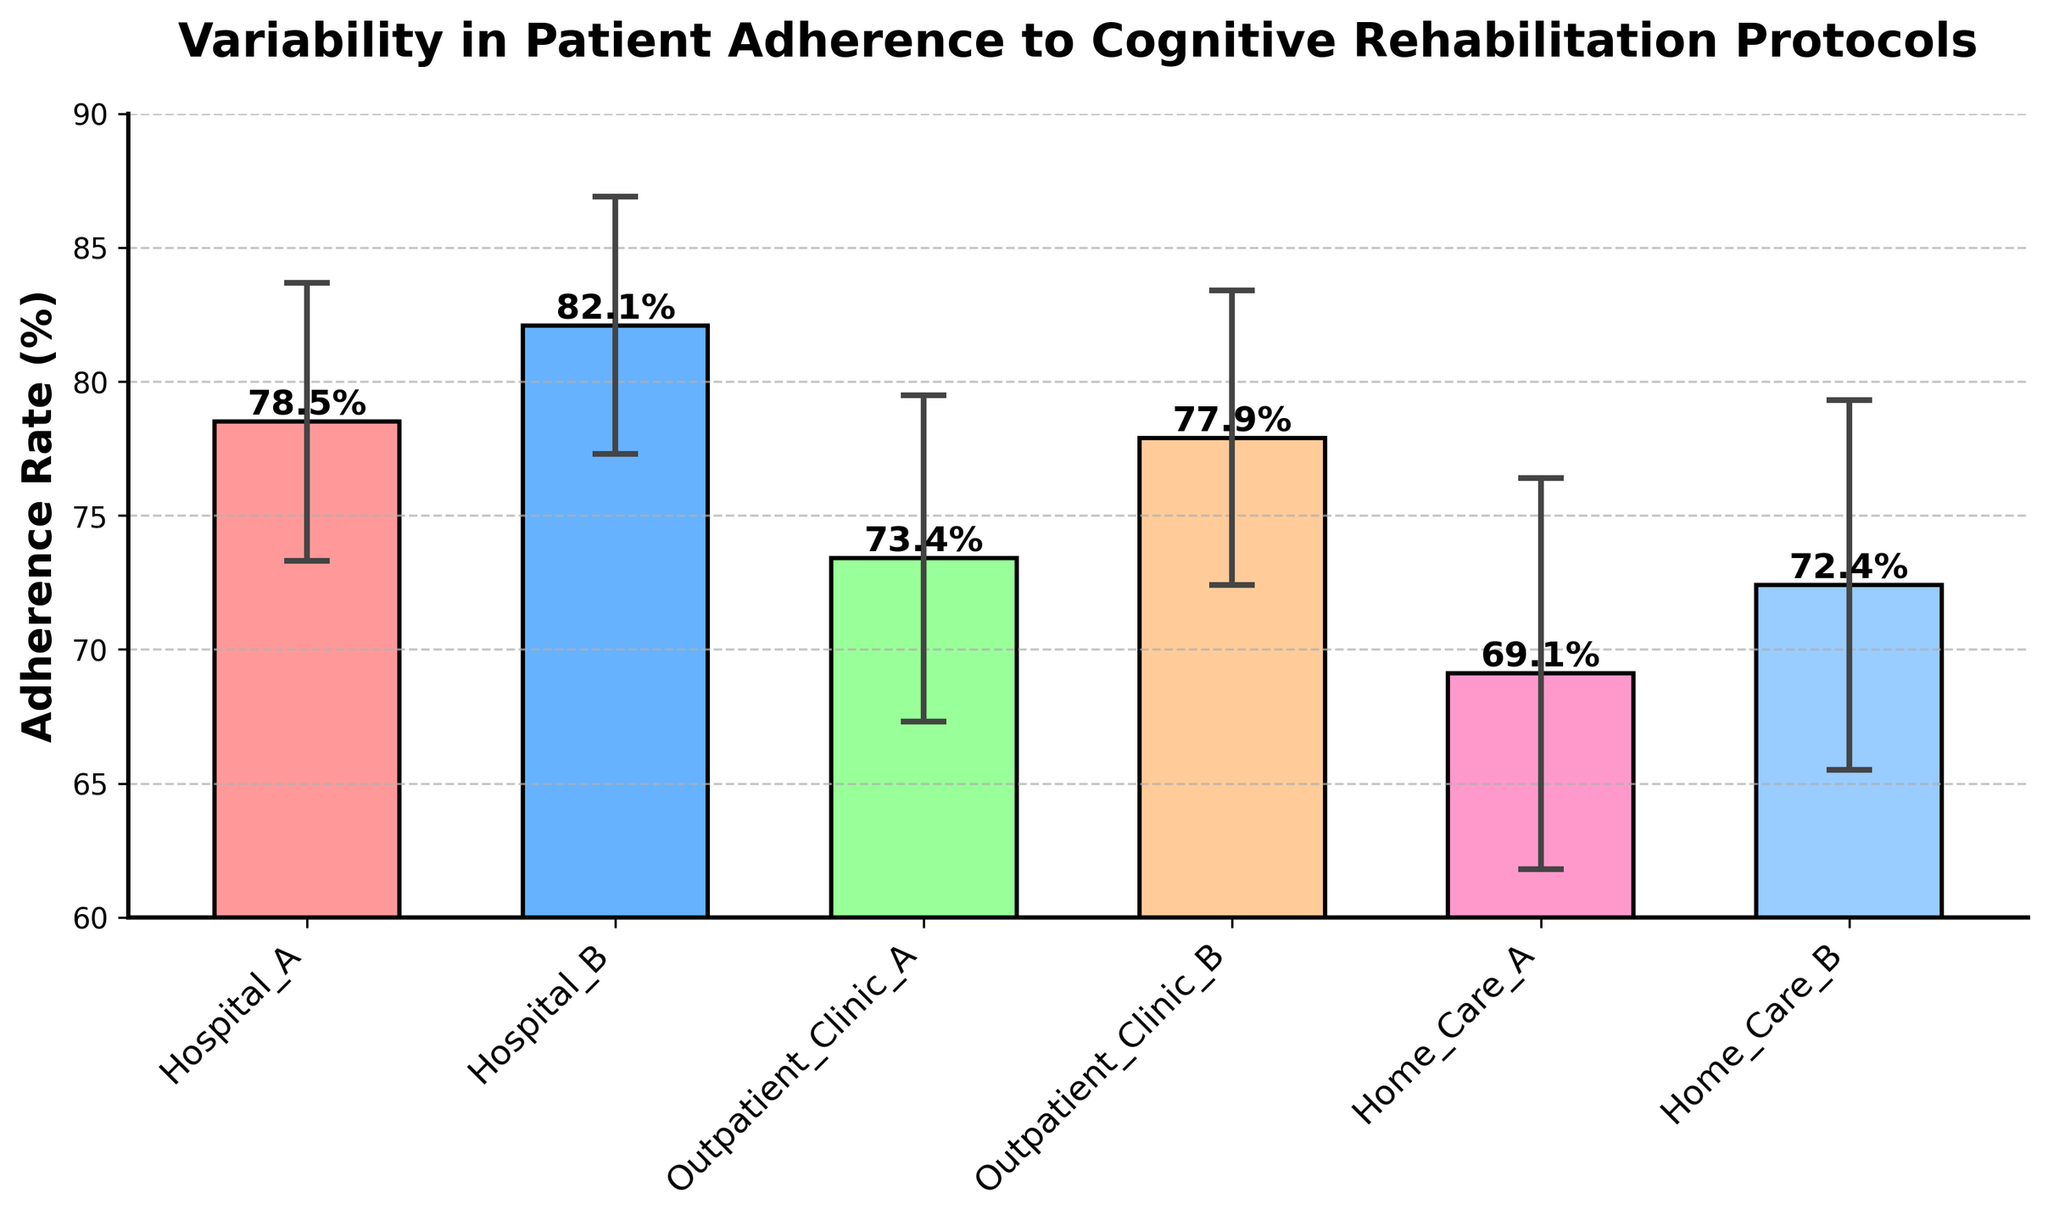What is the title of the figure? The title is the text displayed at the top of the figure, often in a larger or bold font. In this case, the title of the figure is "Variability in Patient Adherence to Cognitive Rehabilitation Protocols".
Answer: Variability in Patient Adherence to Cognitive Rehabilitation Protocols Which clinical setting has the highest adherence rate? To answer this, look for the clinical setting with the tallest bar in the figure. Hospital B has the highest bar, representing the highest adherence rate.
Answer: Hospital B What is the adherence rate for Home Care B? To find this, locate the bar labeled "Home Care B" and read the value at the top of the bar. The figure shows that Home Care B has an adherence rate of 72.4%.
Answer: 72.4% What is the difference in adherence rate between Hospital B and Home Care A? First, determine the adherence rate for Hospital B (82.1%) and Home Care A (69.1%). Then, subtract the adherence rate of Home Care A from Hospital B. 82.1% - 69.1% = 13.0%.
Answer: 13.0% Which clinical setting has the largest variability in adherence, as represented by the error bars? The variability is represented by the length of the error bars. The setting with the longest error bar is Home Care A, with an error of 7.3.
Answer: Home Care A What is the range (max-min) of adherence rates across all settings? Identify the highest and lowest adherence rates among all settings: Hospital B (82.1%) and Home Care A (69.1%), respectively. Subtract the lowest rate from the highest: 82.1% - 69.1% = 13.0%.
Answer: 13.0% Among outpatient clinics, which one has the higher adherence rate? Compare the adherence rates of the two outpatient clinics. Outpatient Clinic A has an adherence rate of 73.4%, and Outpatient Clinic B has a rate of 77.9%. Outpatient Clinic B has the higher rate.
Answer: Outpatient Clinic B What is the average adherence rate across all settings? Calculate the sum of adherence rates: 78.5 + 82.1 + 73.4 + 77.9 + 69.1 + 72.4 = 453.4. Divide by the number of settings (6): 453.4 / 6 = 75.6%.
Answer: 75.6% How does the adherence rate of Hospital A compare to the average adherence rate? First, determine the average adherence rate (75.6%). Then, compare Hospital A's adherence rate (78.5%) to the average. Hospital A's rate is higher than the average.
Answer: Higher Describe the pattern observed in adherence rates between clinical settings (hospitals, outpatient clinics, home care). By comparing adherence rates, hospitals tend to have higher adherence rates (82.1%, 78.5%) than outpatient clinics (77.9%, 73.4%) and home care settings (72.4%, 69.1%).
Answer: Hospitals > Outpatient Clinics > Home Care 